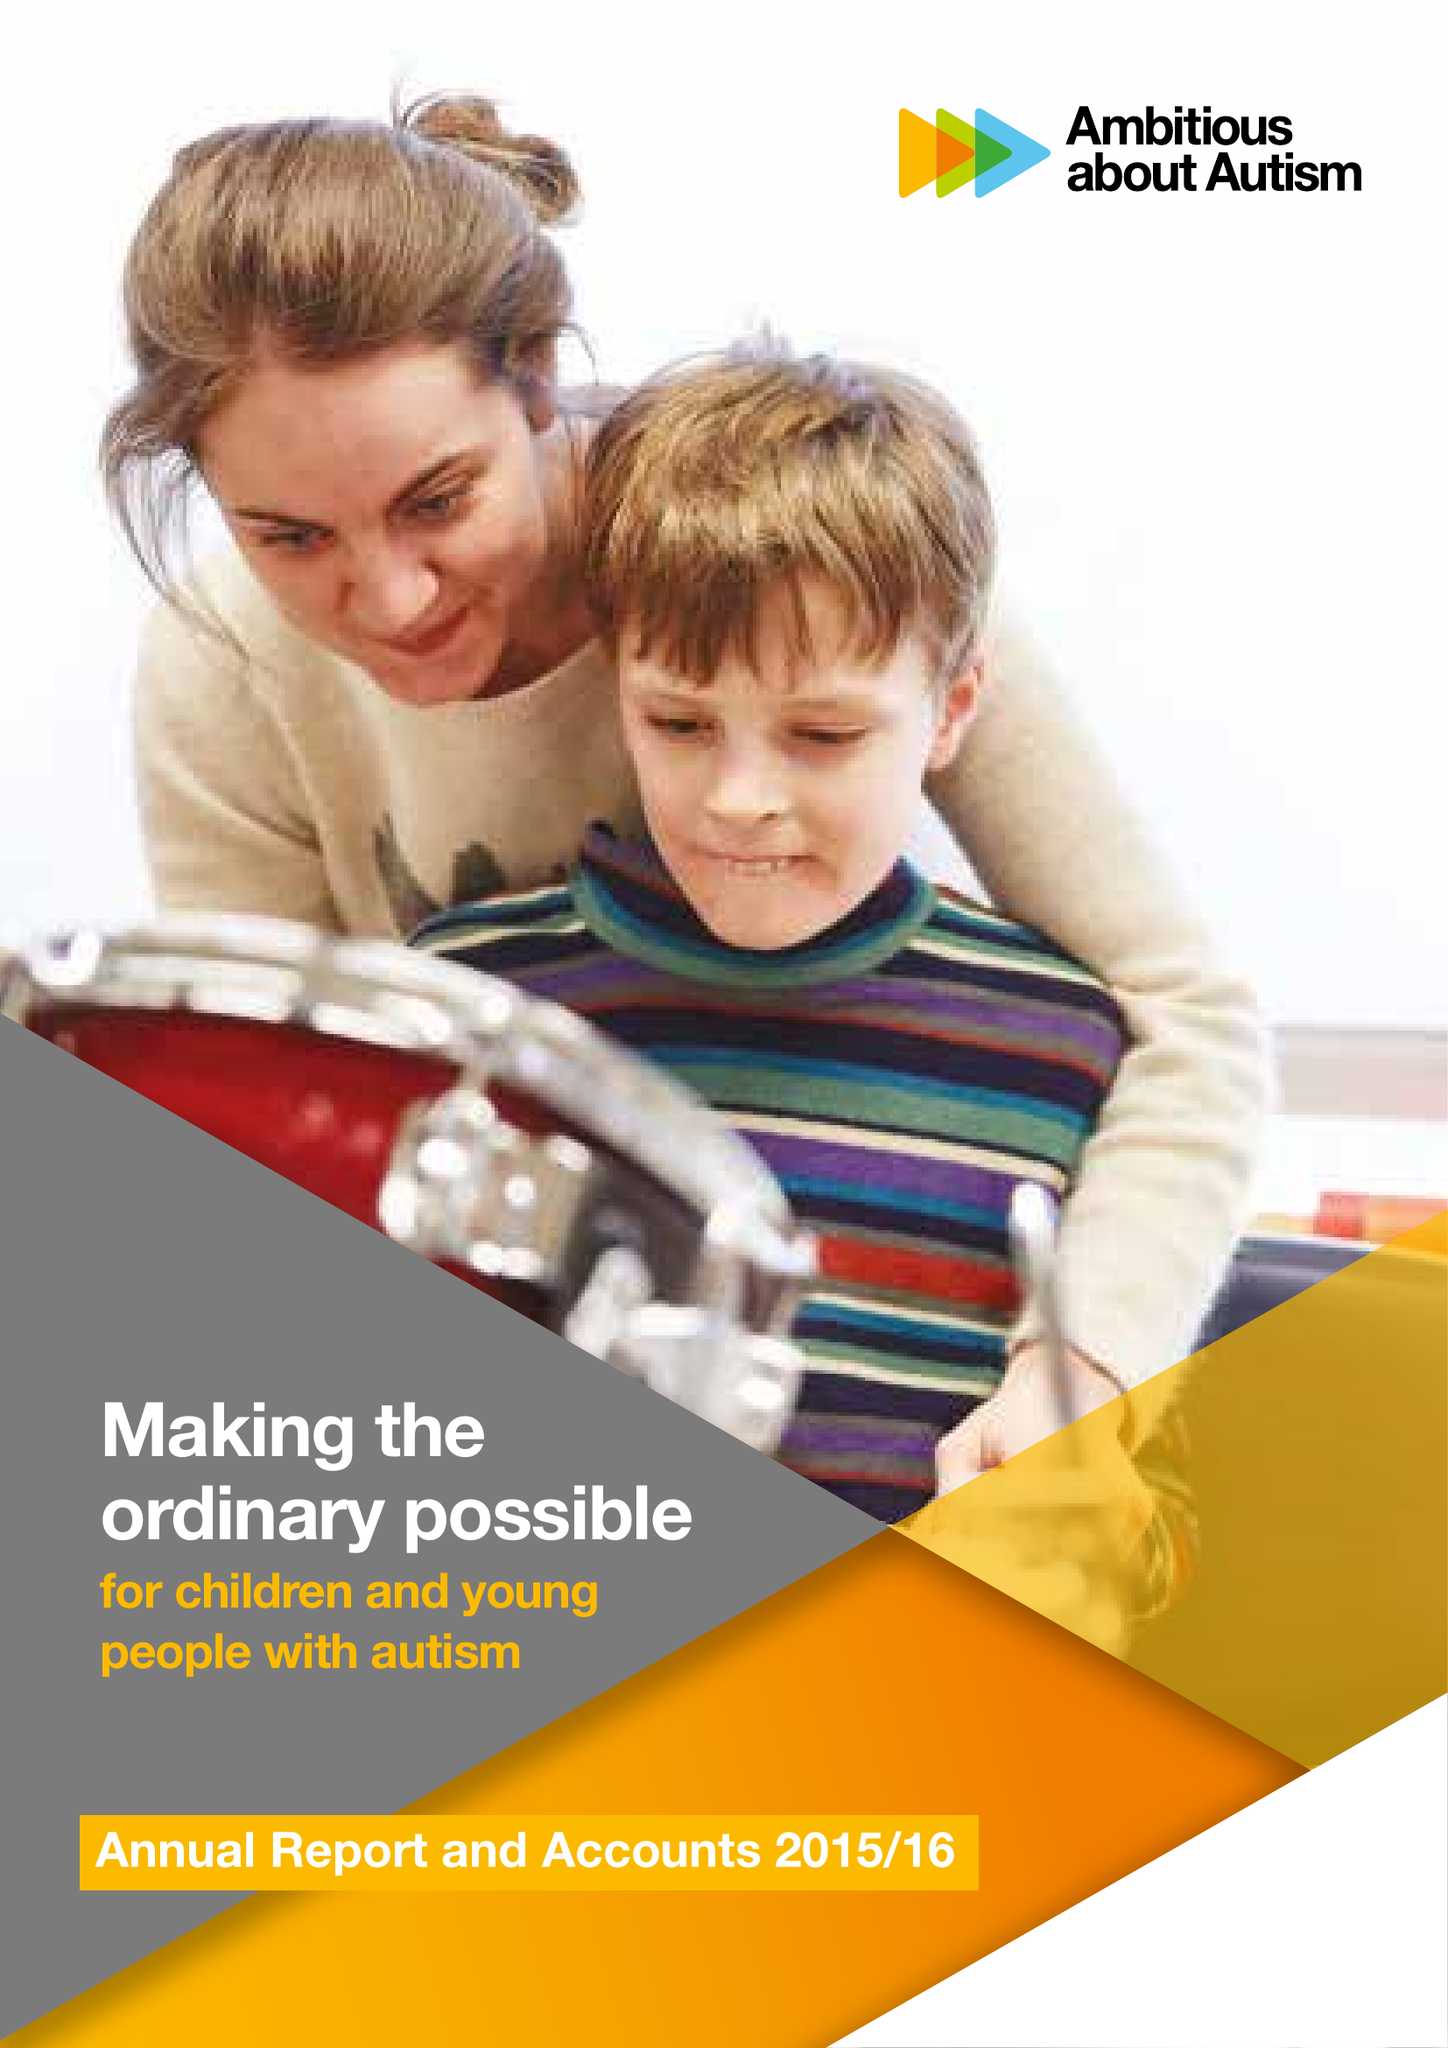What is the value for the address__street_line?
Answer the question using a single word or phrase. None 